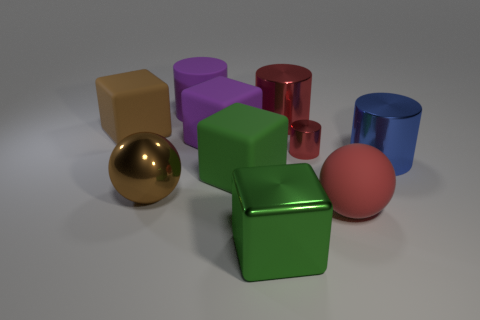Subtract all blue spheres. Subtract all green cylinders. How many spheres are left? 2 Subtract all yellow balls. How many cyan cylinders are left? 0 Add 9 reds. How many tiny things exist? 0 Subtract all large blocks. Subtract all large blue metallic things. How many objects are left? 5 Add 7 large red shiny cylinders. How many large red shiny cylinders are left? 8 Add 9 brown matte cubes. How many brown matte cubes exist? 10 Subtract all brown balls. How many balls are left? 1 Subtract all rubber blocks. How many blocks are left? 1 Subtract 0 yellow cylinders. How many objects are left? 10 Subtract all green cubes. How many were subtracted if there are1green cubes left? 1 